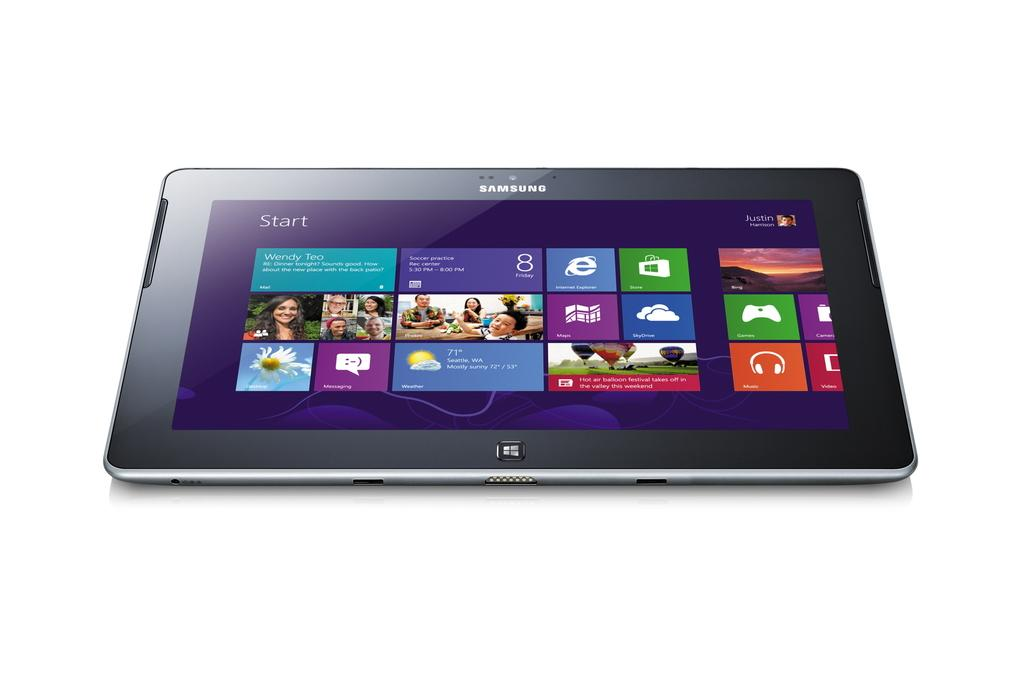What electronic device is visible in the image? There is a Samsung tablet in the image. What color is the background of the image? The background of the image is white. What type of hook is used to hang the Samsung tablet on the wall in the image? There is no hook or wall hanging depicted in the image; the Samsung tablet is simply visible on a surface. What type of territory is the rabbit occupying in the image? There is no rabbit present in the image. 